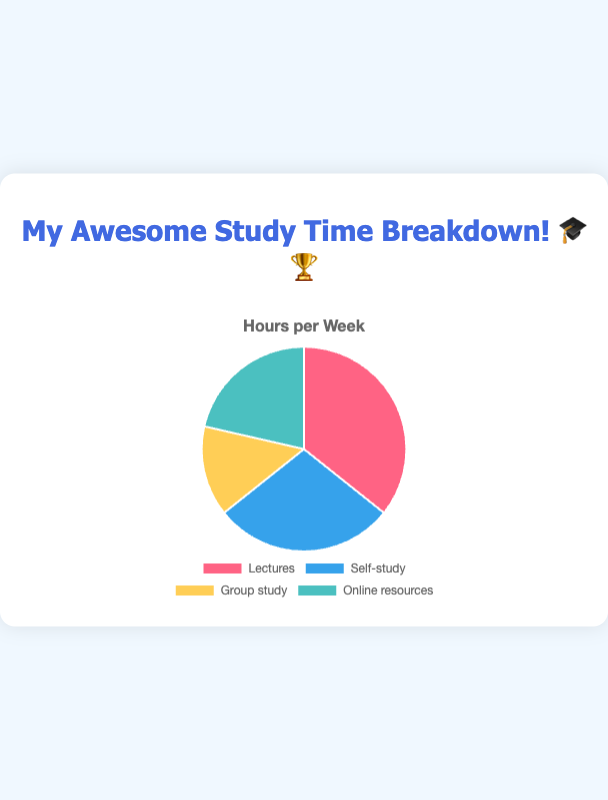Which category has the highest number of hours allocated? The pie chart shows that Lectures have the largest section, indicating the highest number of hours allocated.
Answer: Lectures What's the total study time in a week? Sum the hours from all categories: Lectures (10) + Self-study (8) + Group study (4) + Online resources (6).
Answer: 28 How many more hours are allocated to Lectures compared to Group study? Subtract Group study hours from Lectures hours: 10 (Lectures) - 4 (Group study).
Answer: 6 Which categories combined constitute half of the total study time? Calculate half of the total study time: 28 / 2 = 14. Adding categories: Lectures (10) + Self-study (8) = 18, which is more than half. Thus, one alternative is: Lectures (10) + Online resources (6).
Answer: Lectures and Online resources What is the percentage of total study time devoted to Online resources? Divide Online resources hours by total hours and multiply by 100: (6 / 28) * 100.
Answer: 21.43% Which category has the least number of hours allocated? The pie chart shows that Group study has the smallest section, indicating the least number of hours allocated.
Answer: Group study How do the hours spent on Self-study compare to Online resources? Compare the hours: Self-study (8) is greater than Online resources (6).
Answer: Self-study has more hours What's the difference in hours between the highest and lowest time allocation categories? Subtract the lowest hours (Group study) from the highest hours (Lectures): 10 - 4.
Answer: 6 Which color represents the Self-study category? Refer to the colors in the chart; Self-study is represented by blue.
Answer: Blue What proportion of the week is spent in Group study? Divide Group study hours by total hours: 4 / 28.
Answer: 1/7 